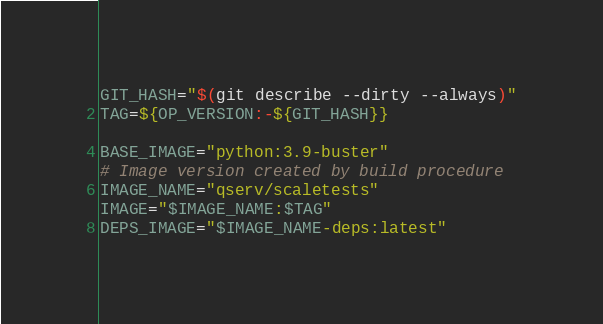Convert code to text. <code><loc_0><loc_0><loc_500><loc_500><_Bash_>GIT_HASH="$(git describe --dirty --always)"
TAG=${OP_VERSION:-${GIT_HASH}}

BASE_IMAGE="python:3.9-buster"
# Image version created by build procedure
IMAGE_NAME="qserv/scaletests"
IMAGE="$IMAGE_NAME:$TAG"
DEPS_IMAGE="$IMAGE_NAME-deps:latest"
</code> 